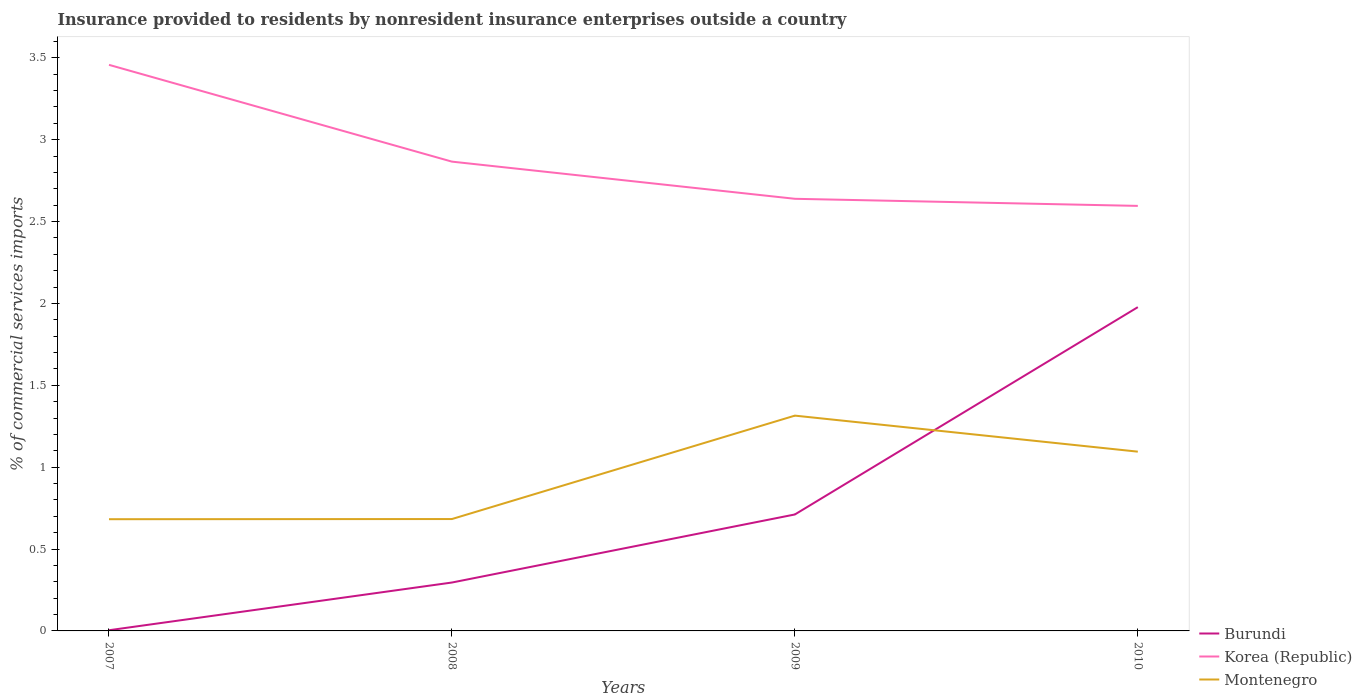Does the line corresponding to Burundi intersect with the line corresponding to Korea (Republic)?
Offer a very short reply. No. Across all years, what is the maximum Insurance provided to residents in Korea (Republic)?
Your response must be concise. 2.6. What is the total Insurance provided to residents in Korea (Republic) in the graph?
Make the answer very short. 0.59. What is the difference between the highest and the second highest Insurance provided to residents in Montenegro?
Ensure brevity in your answer.  0.63. What is the difference between the highest and the lowest Insurance provided to residents in Korea (Republic)?
Make the answer very short. 1. Is the Insurance provided to residents in Montenegro strictly greater than the Insurance provided to residents in Burundi over the years?
Your answer should be compact. No. How many lines are there?
Your response must be concise. 3. Are the values on the major ticks of Y-axis written in scientific E-notation?
Offer a very short reply. No. Does the graph contain any zero values?
Offer a terse response. No. Does the graph contain grids?
Provide a short and direct response. No. Where does the legend appear in the graph?
Offer a very short reply. Bottom right. How many legend labels are there?
Provide a short and direct response. 3. What is the title of the graph?
Ensure brevity in your answer.  Insurance provided to residents by nonresident insurance enterprises outside a country. What is the label or title of the X-axis?
Keep it short and to the point. Years. What is the label or title of the Y-axis?
Give a very brief answer. % of commercial services imports. What is the % of commercial services imports in Burundi in 2007?
Give a very brief answer. 0. What is the % of commercial services imports of Korea (Republic) in 2007?
Your answer should be compact. 3.46. What is the % of commercial services imports of Montenegro in 2007?
Provide a short and direct response. 0.68. What is the % of commercial services imports of Burundi in 2008?
Your answer should be very brief. 0.3. What is the % of commercial services imports in Korea (Republic) in 2008?
Provide a short and direct response. 2.87. What is the % of commercial services imports in Montenegro in 2008?
Offer a terse response. 0.68. What is the % of commercial services imports of Burundi in 2009?
Your answer should be compact. 0.71. What is the % of commercial services imports of Korea (Republic) in 2009?
Ensure brevity in your answer.  2.64. What is the % of commercial services imports of Montenegro in 2009?
Offer a terse response. 1.31. What is the % of commercial services imports of Burundi in 2010?
Keep it short and to the point. 1.98. What is the % of commercial services imports in Korea (Republic) in 2010?
Offer a terse response. 2.6. What is the % of commercial services imports in Montenegro in 2010?
Provide a succinct answer. 1.09. Across all years, what is the maximum % of commercial services imports in Burundi?
Ensure brevity in your answer.  1.98. Across all years, what is the maximum % of commercial services imports in Korea (Republic)?
Make the answer very short. 3.46. Across all years, what is the maximum % of commercial services imports of Montenegro?
Keep it short and to the point. 1.31. Across all years, what is the minimum % of commercial services imports in Burundi?
Make the answer very short. 0. Across all years, what is the minimum % of commercial services imports in Korea (Republic)?
Offer a very short reply. 2.6. Across all years, what is the minimum % of commercial services imports of Montenegro?
Offer a terse response. 0.68. What is the total % of commercial services imports in Burundi in the graph?
Your answer should be compact. 2.99. What is the total % of commercial services imports of Korea (Republic) in the graph?
Offer a terse response. 11.56. What is the total % of commercial services imports in Montenegro in the graph?
Give a very brief answer. 3.77. What is the difference between the % of commercial services imports of Burundi in 2007 and that in 2008?
Your response must be concise. -0.29. What is the difference between the % of commercial services imports in Korea (Republic) in 2007 and that in 2008?
Keep it short and to the point. 0.59. What is the difference between the % of commercial services imports of Montenegro in 2007 and that in 2008?
Provide a succinct answer. -0. What is the difference between the % of commercial services imports of Burundi in 2007 and that in 2009?
Provide a short and direct response. -0.71. What is the difference between the % of commercial services imports in Korea (Republic) in 2007 and that in 2009?
Make the answer very short. 0.82. What is the difference between the % of commercial services imports of Montenegro in 2007 and that in 2009?
Your response must be concise. -0.63. What is the difference between the % of commercial services imports of Burundi in 2007 and that in 2010?
Provide a short and direct response. -1.97. What is the difference between the % of commercial services imports of Korea (Republic) in 2007 and that in 2010?
Provide a short and direct response. 0.86. What is the difference between the % of commercial services imports of Montenegro in 2007 and that in 2010?
Your response must be concise. -0.41. What is the difference between the % of commercial services imports of Burundi in 2008 and that in 2009?
Provide a short and direct response. -0.42. What is the difference between the % of commercial services imports of Korea (Republic) in 2008 and that in 2009?
Offer a very short reply. 0.23. What is the difference between the % of commercial services imports in Montenegro in 2008 and that in 2009?
Your answer should be compact. -0.63. What is the difference between the % of commercial services imports in Burundi in 2008 and that in 2010?
Your response must be concise. -1.68. What is the difference between the % of commercial services imports of Korea (Republic) in 2008 and that in 2010?
Provide a succinct answer. 0.27. What is the difference between the % of commercial services imports of Montenegro in 2008 and that in 2010?
Provide a short and direct response. -0.41. What is the difference between the % of commercial services imports in Burundi in 2009 and that in 2010?
Give a very brief answer. -1.27. What is the difference between the % of commercial services imports of Korea (Republic) in 2009 and that in 2010?
Give a very brief answer. 0.04. What is the difference between the % of commercial services imports of Montenegro in 2009 and that in 2010?
Your answer should be very brief. 0.22. What is the difference between the % of commercial services imports of Burundi in 2007 and the % of commercial services imports of Korea (Republic) in 2008?
Provide a short and direct response. -2.86. What is the difference between the % of commercial services imports in Burundi in 2007 and the % of commercial services imports in Montenegro in 2008?
Ensure brevity in your answer.  -0.68. What is the difference between the % of commercial services imports in Korea (Republic) in 2007 and the % of commercial services imports in Montenegro in 2008?
Make the answer very short. 2.77. What is the difference between the % of commercial services imports of Burundi in 2007 and the % of commercial services imports of Korea (Republic) in 2009?
Your answer should be very brief. -2.63. What is the difference between the % of commercial services imports in Burundi in 2007 and the % of commercial services imports in Montenegro in 2009?
Provide a succinct answer. -1.31. What is the difference between the % of commercial services imports in Korea (Republic) in 2007 and the % of commercial services imports in Montenegro in 2009?
Give a very brief answer. 2.14. What is the difference between the % of commercial services imports in Burundi in 2007 and the % of commercial services imports in Korea (Republic) in 2010?
Your response must be concise. -2.59. What is the difference between the % of commercial services imports in Burundi in 2007 and the % of commercial services imports in Montenegro in 2010?
Ensure brevity in your answer.  -1.09. What is the difference between the % of commercial services imports of Korea (Republic) in 2007 and the % of commercial services imports of Montenegro in 2010?
Make the answer very short. 2.36. What is the difference between the % of commercial services imports in Burundi in 2008 and the % of commercial services imports in Korea (Republic) in 2009?
Offer a very short reply. -2.34. What is the difference between the % of commercial services imports in Burundi in 2008 and the % of commercial services imports in Montenegro in 2009?
Keep it short and to the point. -1.02. What is the difference between the % of commercial services imports of Korea (Republic) in 2008 and the % of commercial services imports of Montenegro in 2009?
Offer a very short reply. 1.55. What is the difference between the % of commercial services imports of Burundi in 2008 and the % of commercial services imports of Korea (Republic) in 2010?
Your response must be concise. -2.3. What is the difference between the % of commercial services imports in Burundi in 2008 and the % of commercial services imports in Montenegro in 2010?
Your answer should be very brief. -0.8. What is the difference between the % of commercial services imports of Korea (Republic) in 2008 and the % of commercial services imports of Montenegro in 2010?
Give a very brief answer. 1.77. What is the difference between the % of commercial services imports in Burundi in 2009 and the % of commercial services imports in Korea (Republic) in 2010?
Your response must be concise. -1.88. What is the difference between the % of commercial services imports of Burundi in 2009 and the % of commercial services imports of Montenegro in 2010?
Offer a very short reply. -0.38. What is the difference between the % of commercial services imports of Korea (Republic) in 2009 and the % of commercial services imports of Montenegro in 2010?
Ensure brevity in your answer.  1.54. What is the average % of commercial services imports in Burundi per year?
Ensure brevity in your answer.  0.75. What is the average % of commercial services imports of Korea (Republic) per year?
Your response must be concise. 2.89. What is the average % of commercial services imports of Montenegro per year?
Give a very brief answer. 0.94. In the year 2007, what is the difference between the % of commercial services imports of Burundi and % of commercial services imports of Korea (Republic)?
Offer a very short reply. -3.45. In the year 2007, what is the difference between the % of commercial services imports of Burundi and % of commercial services imports of Montenegro?
Your answer should be very brief. -0.68. In the year 2007, what is the difference between the % of commercial services imports in Korea (Republic) and % of commercial services imports in Montenegro?
Ensure brevity in your answer.  2.77. In the year 2008, what is the difference between the % of commercial services imports of Burundi and % of commercial services imports of Korea (Republic)?
Your response must be concise. -2.57. In the year 2008, what is the difference between the % of commercial services imports in Burundi and % of commercial services imports in Montenegro?
Give a very brief answer. -0.39. In the year 2008, what is the difference between the % of commercial services imports in Korea (Republic) and % of commercial services imports in Montenegro?
Your answer should be compact. 2.18. In the year 2009, what is the difference between the % of commercial services imports of Burundi and % of commercial services imports of Korea (Republic)?
Make the answer very short. -1.93. In the year 2009, what is the difference between the % of commercial services imports of Burundi and % of commercial services imports of Montenegro?
Ensure brevity in your answer.  -0.6. In the year 2009, what is the difference between the % of commercial services imports in Korea (Republic) and % of commercial services imports in Montenegro?
Provide a short and direct response. 1.32. In the year 2010, what is the difference between the % of commercial services imports of Burundi and % of commercial services imports of Korea (Republic)?
Your answer should be compact. -0.62. In the year 2010, what is the difference between the % of commercial services imports in Burundi and % of commercial services imports in Montenegro?
Your response must be concise. 0.88. In the year 2010, what is the difference between the % of commercial services imports in Korea (Republic) and % of commercial services imports in Montenegro?
Your response must be concise. 1.5. What is the ratio of the % of commercial services imports in Burundi in 2007 to that in 2008?
Your response must be concise. 0.01. What is the ratio of the % of commercial services imports of Korea (Republic) in 2007 to that in 2008?
Your answer should be very brief. 1.21. What is the ratio of the % of commercial services imports of Montenegro in 2007 to that in 2008?
Provide a short and direct response. 1. What is the ratio of the % of commercial services imports in Burundi in 2007 to that in 2009?
Ensure brevity in your answer.  0.01. What is the ratio of the % of commercial services imports of Korea (Republic) in 2007 to that in 2009?
Make the answer very short. 1.31. What is the ratio of the % of commercial services imports in Montenegro in 2007 to that in 2009?
Keep it short and to the point. 0.52. What is the ratio of the % of commercial services imports of Burundi in 2007 to that in 2010?
Your response must be concise. 0. What is the ratio of the % of commercial services imports of Korea (Republic) in 2007 to that in 2010?
Offer a terse response. 1.33. What is the ratio of the % of commercial services imports in Montenegro in 2007 to that in 2010?
Make the answer very short. 0.62. What is the ratio of the % of commercial services imports in Burundi in 2008 to that in 2009?
Your answer should be very brief. 0.42. What is the ratio of the % of commercial services imports of Korea (Republic) in 2008 to that in 2009?
Give a very brief answer. 1.09. What is the ratio of the % of commercial services imports in Montenegro in 2008 to that in 2009?
Offer a terse response. 0.52. What is the ratio of the % of commercial services imports in Burundi in 2008 to that in 2010?
Make the answer very short. 0.15. What is the ratio of the % of commercial services imports of Korea (Republic) in 2008 to that in 2010?
Make the answer very short. 1.1. What is the ratio of the % of commercial services imports in Montenegro in 2008 to that in 2010?
Ensure brevity in your answer.  0.62. What is the ratio of the % of commercial services imports in Burundi in 2009 to that in 2010?
Your response must be concise. 0.36. What is the ratio of the % of commercial services imports of Korea (Republic) in 2009 to that in 2010?
Provide a succinct answer. 1.02. What is the ratio of the % of commercial services imports in Montenegro in 2009 to that in 2010?
Provide a succinct answer. 1.2. What is the difference between the highest and the second highest % of commercial services imports in Burundi?
Keep it short and to the point. 1.27. What is the difference between the highest and the second highest % of commercial services imports in Korea (Republic)?
Your answer should be compact. 0.59. What is the difference between the highest and the second highest % of commercial services imports of Montenegro?
Your answer should be very brief. 0.22. What is the difference between the highest and the lowest % of commercial services imports in Burundi?
Provide a short and direct response. 1.97. What is the difference between the highest and the lowest % of commercial services imports in Korea (Republic)?
Your answer should be compact. 0.86. What is the difference between the highest and the lowest % of commercial services imports of Montenegro?
Provide a short and direct response. 0.63. 